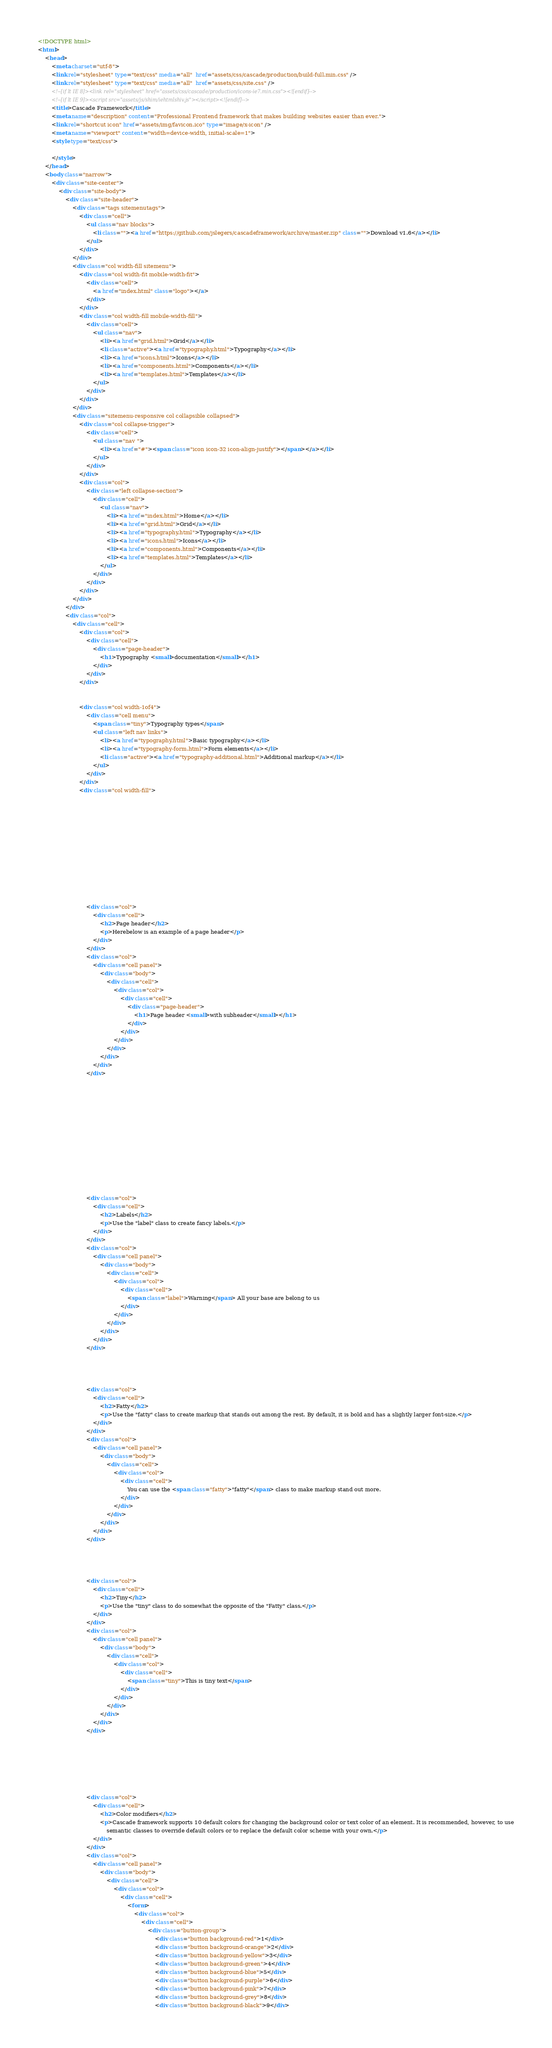<code> <loc_0><loc_0><loc_500><loc_500><_HTML_><!DOCTYPE html>
<html>
    <head>
        <meta charset="utf-8">
        <link rel="stylesheet" type="text/css" media="all"  href="assets/css/cascade/production/build-full.min.css" />
        <link rel="stylesheet" type="text/css" media="all"  href="assets/css/site.css" />
        <!--[if lt IE 8]><link rel="stylesheet" href="assets/css/cascade/production/icons-ie7.min.css"><![endif]-->
        <!--[if lt IE 9]><script src="assets/js/shim/iehtmlshiv.js"></script><![endif]-->
        <title>Cascade Framework</title>
        <meta name="description" content="Professional Frontend framework that makes building websites easier than ever.">
        <link rel="shortcut icon" href="assets/img/favicon.ico" type="image/x-icon" />
        <meta name="viewport" content="width=device-width, initial-scale=1">
        <style type="text/css">

        </style>
    </head>
    <body class="narrow">
        <div class="site-center">
            <div class="site-body">
                <div class="site-header">
                    <div class="tags sitemenutags">
                        <div class="cell">
                            <ul class="nav blocks">
                                <li class=""><a href="https://github.com/jslegers/cascadeframework/archive/master.zip" class="">Download v1.6</a></li>
                            </ul>
                        </div>
                    </div>
                    <div class="col width-fill sitemenu">
                        <div class="col width-fit mobile-width-fit">
                            <div class="cell">
                                <a href="index.html" class="logo"></a>
                            </div>
                        </div>
                        <div class="col width-fill mobile-width-fill">
                            <div class="cell">
                                <ul class="nav">
                                    <li><a href="grid.html">Grid</a></li>
                                    <li class="active"><a href="typography.html">Typography</a></li>
                                    <li><a href="icons.html">Icons</a></li>
                                    <li><a href="components.html">Components</a></li>
                                    <li><a href="templates.html">Templates</a></li>
                                </ul>
                            </div>
                        </div>
                    </div>
                    <div class="sitemenu-responsive col collapsible collapsed">
                        <div class="col collapse-trigger">
                            <div class="cell">
                                <ul class="nav ">
                                    <li><a href="#"><span class="icon icon-32 icon-align-justify"></span></a></li>
                                </ul>
                            </div>
                        </div>
                        <div class="col">
                            <div class="left collapse-section">
                                <div class="cell">
                                    <ul class="nav">
                                        <li><a href="index.html">Home</a></li>
                                        <li><a href="grid.html">Grid</a></li>
                                        <li><a href="typography.html">Typography</a></li>
                                        <li><a href="icons.html">Icons</a></li>
                                        <li><a href="components.html">Components</a></li>
                                        <li><a href="templates.html">Templates</a></li>
                                    </ul>
                                </div>
                            </div>
                        </div>
                    </div>
                </div>
                <div class="col">
                    <div class="cell">
                        <div class="col">
                            <div class="cell">
                                <div class="page-header">
                                    <h1>Typography <small>documentation</small></h1>
                                </div>
                            </div>
                        </div>


                        <div class="col width-1of4">
                            <div class="cell menu">
                                <span class="tiny">Typography types</span>
                                <ul class="left nav links">
                                    <li><a href="typography.html">Basic typography</a></li>
                                    <li><a href="typography-form.html">Form elements</a></li>
                                    <li class="active"><a href="typography-additional.html">Additional markup</a></li>
                                </ul>
                            </div>
                        </div>
                        <div class="col width-fill">













                            <div class="col">
                                <div class="cell">
                                    <h2>Page header</h2>
                                    <p>Herebelow is an example of a page header</p>
                                </div>
                            </div>
                            <div class="col">
                                <div class="cell panel">
                                    <div class="body">
                                        <div class="cell">
                                            <div class="col">
                                                <div class="cell">
                                                    <div class="page-header">
                                                        <h1>Page header <small>with subheader</small></h1>
                                                    </div>
                                                </div>
                                            </div>
                                        </div>
                                    </div>
                                </div>
                            </div>














                            <div class="col">
                                <div class="cell">
                                    <h2>Labels</h2>
                                    <p>Use the "label" class to create fancy labels.</p>
                                </div>
                            </div>
                            <div class="col">
                                <div class="cell panel">
                                    <div class="body">
                                        <div class="cell">
                                            <div class="col">
                                                <div class="cell">
                                                    <span class="label">Warning</span> All your base are belong to us
                                                </div>
                                            </div>
                                        </div>
                                    </div>
                                </div>
                            </div>




                            <div class="col">
                                <div class="cell">
                                    <h2>Fatty</h2>
                                    <p>Use the "fatty" class to create markup that stands out among the rest. By default, it is bold and has a slightly larger font-size.</p>
                                </div>
                            </div>
                            <div class="col">
                                <div class="cell panel">
                                    <div class="body">
                                        <div class="cell">
                                            <div class="col">
                                                <div class="cell">
                                                    You can use the <span class="fatty">"fatty"</span> class to make markup stand out more.
                                                </div>
                                            </div>
                                        </div>
                                    </div>
                                </div>
                            </div>




                            <div class="col">
                                <div class="cell">
                                    <h2>Tiny</h2>
                                    <p>Use the "tiny" class to do somewhat the opposite of the "Fatty" class.</p>
                                </div>
                            </div>
                            <div class="col">
                                <div class="cell panel">
                                    <div class="body">
                                        <div class="cell">
                                            <div class="col">
                                                <div class="cell">
                                                    <span class="tiny">This is tiny text</span>
                                                </div>
                                            </div>
                                        </div>
                                    </div>
                                </div>
                            </div>







                            <div class="col">
                                <div class="cell">
                                    <h2>Color modifiers</h2>
                                    <p>Cascade framework supports 10 default colors for changing the background color or text color of an element. It is recommended, however, to use
                                        semantic classes to override default colors or to replace the default color scheme with your own.</p>
                                </div>
                            </div>
                            <div class="col">
                                <div class="cell panel">
                                    <div class="body">
                                        <div class="cell">
                                            <div class="col">
                                                <div class="cell">
                                                    <form>
                                                        <div class="col">
                                                            <div class="cell">
                                                                <div class="button-group">
                                                                    <div class="button background-red">1</div>
                                                                    <div class="button background-orange">2</div>
                                                                    <div class="button background-yellow">3</div>
                                                                    <div class="button background-green">4</div>
                                                                    <div class="button background-blue">5</div>
                                                                    <div class="button background-purple">6</div>
                                                                    <div class="button background-pink">7</div>
                                                                    <div class="button background-grey">8</div>
                                                                    <div class="button background-black">9</div></code> 